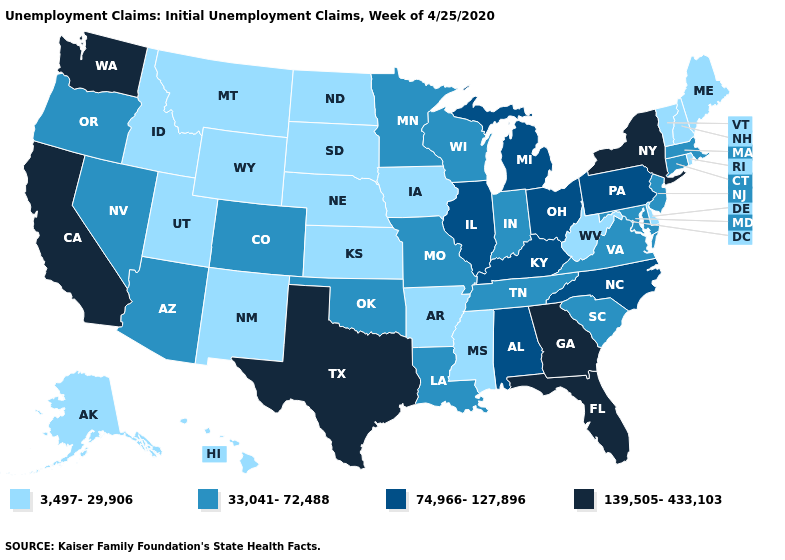What is the value of Louisiana?
Answer briefly. 33,041-72,488. Name the states that have a value in the range 3,497-29,906?
Be succinct. Alaska, Arkansas, Delaware, Hawaii, Idaho, Iowa, Kansas, Maine, Mississippi, Montana, Nebraska, New Hampshire, New Mexico, North Dakota, Rhode Island, South Dakota, Utah, Vermont, West Virginia, Wyoming. What is the lowest value in the USA?
Keep it brief. 3,497-29,906. Name the states that have a value in the range 3,497-29,906?
Be succinct. Alaska, Arkansas, Delaware, Hawaii, Idaho, Iowa, Kansas, Maine, Mississippi, Montana, Nebraska, New Hampshire, New Mexico, North Dakota, Rhode Island, South Dakota, Utah, Vermont, West Virginia, Wyoming. What is the lowest value in the South?
Quick response, please. 3,497-29,906. What is the value of Hawaii?
Quick response, please. 3,497-29,906. What is the lowest value in states that border Rhode Island?
Give a very brief answer. 33,041-72,488. Which states have the lowest value in the MidWest?
Be succinct. Iowa, Kansas, Nebraska, North Dakota, South Dakota. Does the first symbol in the legend represent the smallest category?
Concise answer only. Yes. Does Florida have the highest value in the South?
Keep it brief. Yes. Does Illinois have the lowest value in the USA?
Short answer required. No. Does the first symbol in the legend represent the smallest category?
Short answer required. Yes. What is the lowest value in the South?
Write a very short answer. 3,497-29,906. Is the legend a continuous bar?
Keep it brief. No. How many symbols are there in the legend?
Answer briefly. 4. 